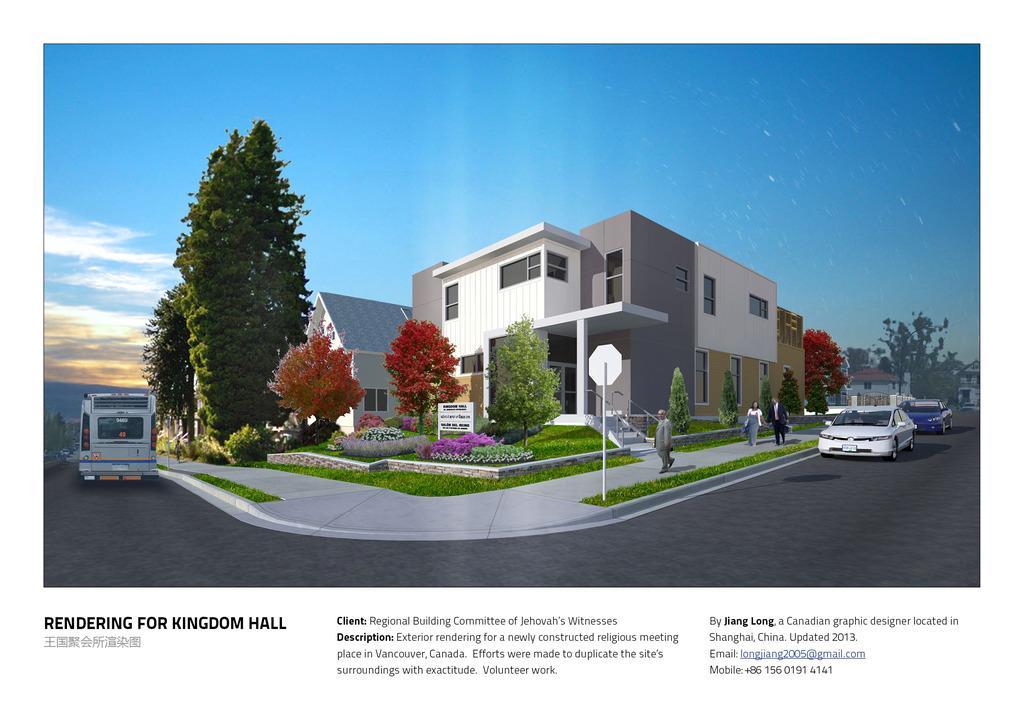Please provide a concise description of this image. In this picture I can see the trees and buildings in the middle, there are vehicles on either side of this image, on the right side few persons are walking. At the top there is the sky, at the bottom there is the text. It is an animation. 